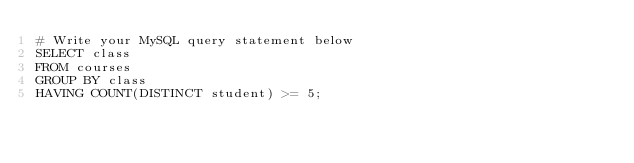<code> <loc_0><loc_0><loc_500><loc_500><_SQL_># Write your MySQL query statement below
SELECT class
FROM courses
GROUP BY class
HAVING COUNT(DISTINCT student) >= 5;
</code> 